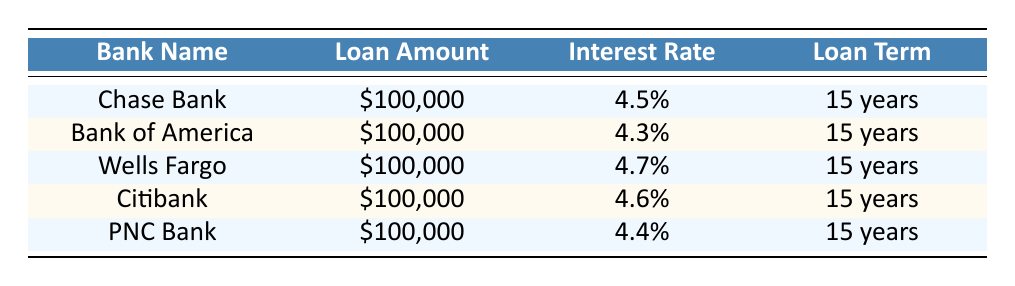What is the interest rate for Bank of America? From the table, we can directly see that the interest rate listed for Bank of America is 4.3%.
Answer: 4.3% Which bank offers the highest interest rate? By looking across the interest rates for each bank listed, Wells Fargo has the highest rate at 4.7%.
Answer: Wells Fargo What is the average interest rate for the restoration project loans across the banks? To find the average, add together all the interest rates: (4.5 + 4.3 + 4.7 + 4.6 + 4.4) = 22.5. Then divide by the number of banks (5): 22.5 / 5 = 4.5.
Answer: 4.5% Is Citibank's interest rate lower than that of Chase Bank? The interest rate for Citibank is 4.6% and for Chase Bank it is 4.5%. Since 4.6% is not lower than 4.5%, the statement is false.
Answer: No Which bank has a loan term of 15 years with the second lowest interest rate? Looking at the interest rates, after Bank of America (4.3%) which has the lowest, PNC Bank has the second lowest interest rate at 4.4%. Both have a loan term of 15 years.
Answer: PNC Bank 